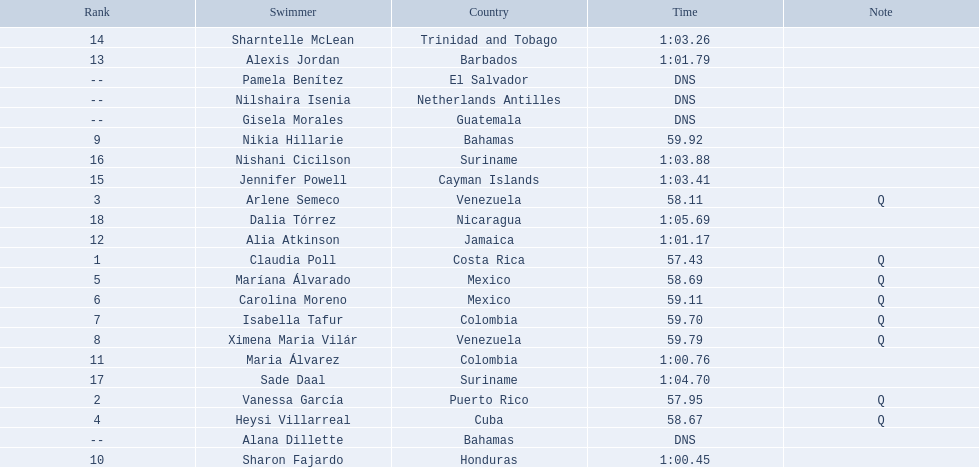Where were the top eight finishers from? Costa Rica, Puerto Rico, Venezuela, Cuba, Mexico, Mexico, Colombia, Venezuela. Which of the top eight were from cuba? Heysi Villarreal. 